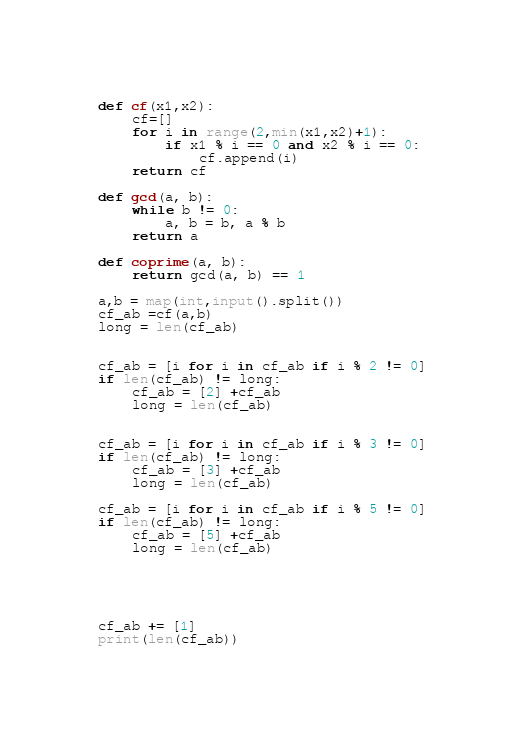Convert code to text. <code><loc_0><loc_0><loc_500><loc_500><_Python_>def cf(x1,x2):
    cf=[]
    for i in range(2,min(x1,x2)+1):
        if x1 % i == 0 and x2 % i == 0:
            cf.append(i)
    return cf

def gcd(a, b):
    while b != 0:
        a, b = b, a % b
    return a

def coprime(a, b):
    return gcd(a, b) == 1

a,b = map(int,input().split())
cf_ab =cf(a,b)
long = len(cf_ab)


cf_ab = [i for i in cf_ab if i % 2 != 0]
if len(cf_ab) != long:
    cf_ab = [2] +cf_ab
    long = len(cf_ab)


cf_ab = [i for i in cf_ab if i % 3 != 0]
if len(cf_ab) != long:
    cf_ab = [3] +cf_ab
    long = len(cf_ab)

cf_ab = [i for i in cf_ab if i % 5 != 0]
if len(cf_ab) != long:
    cf_ab = [5] +cf_ab
    long = len(cf_ab)





cf_ab += [1]
print(len(cf_ab))
</code> 